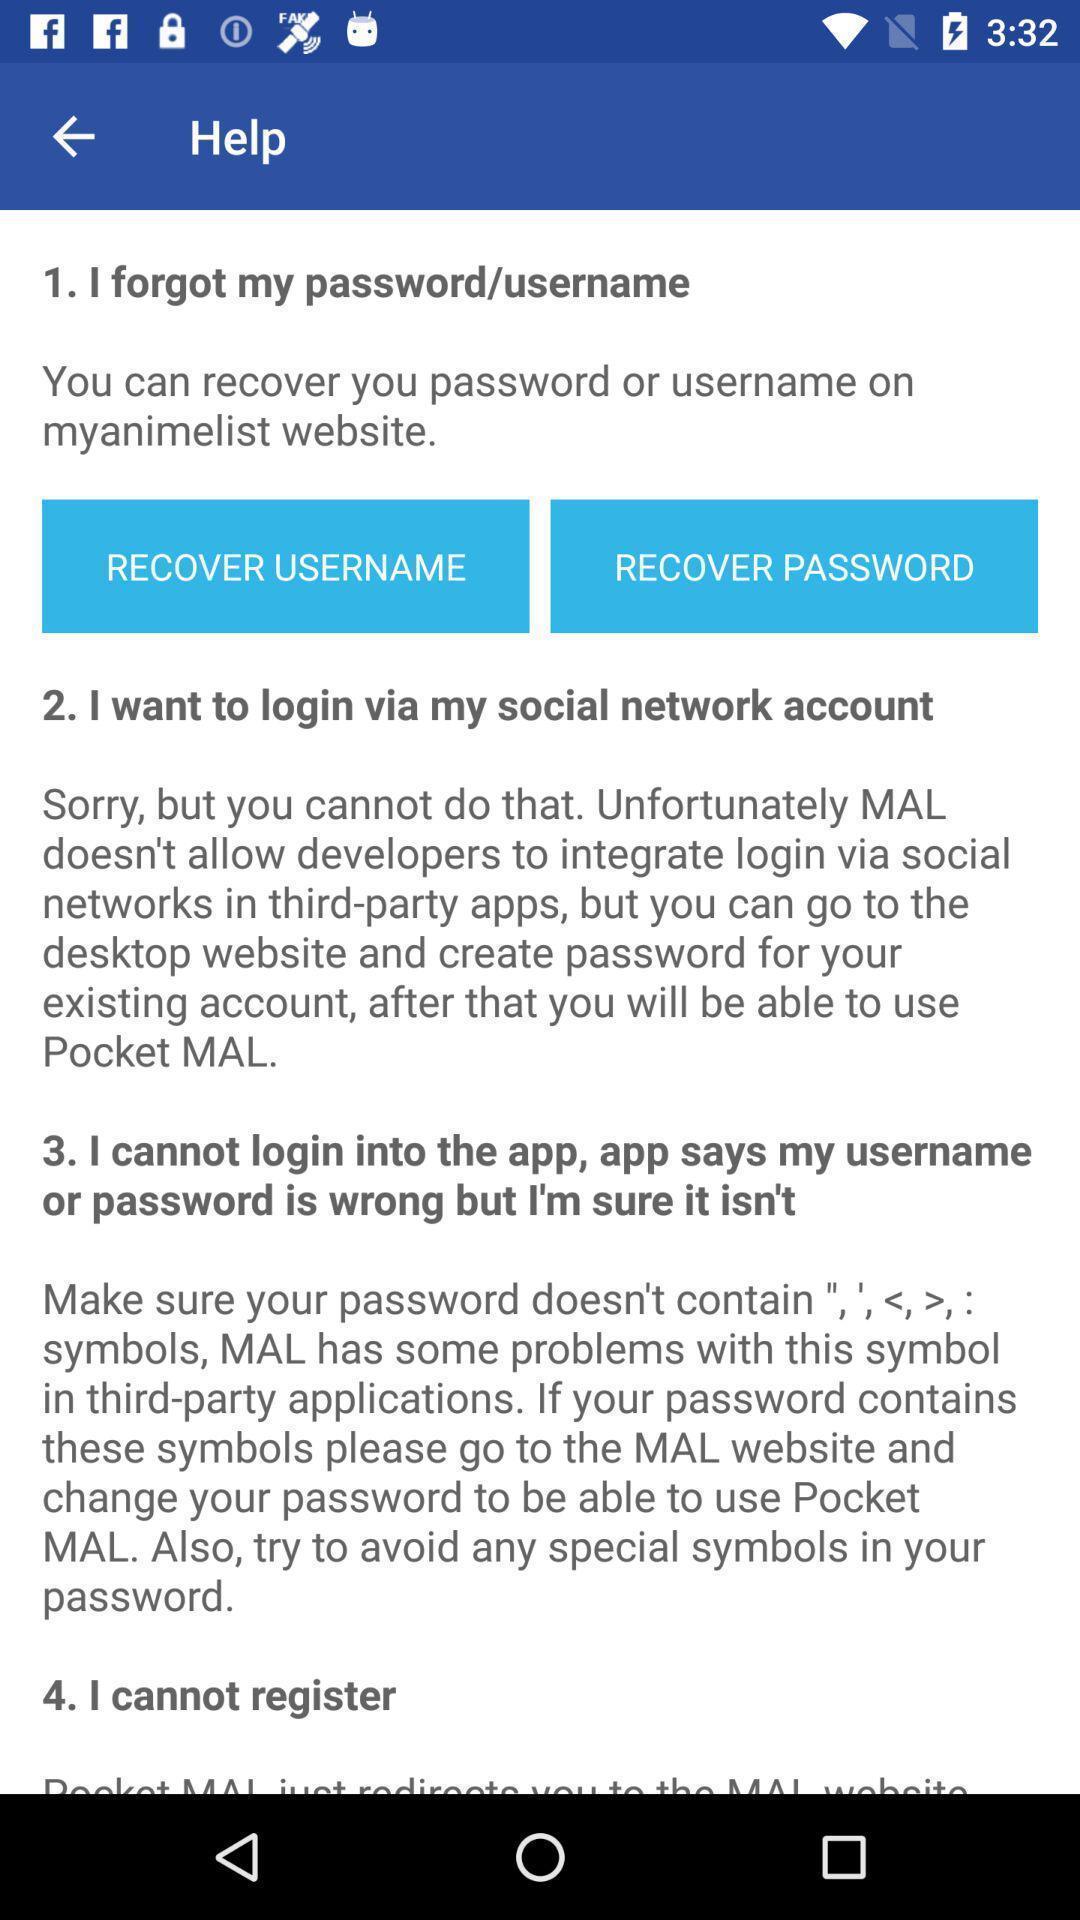Provide a detailed account of this screenshot. Page with the help options. 